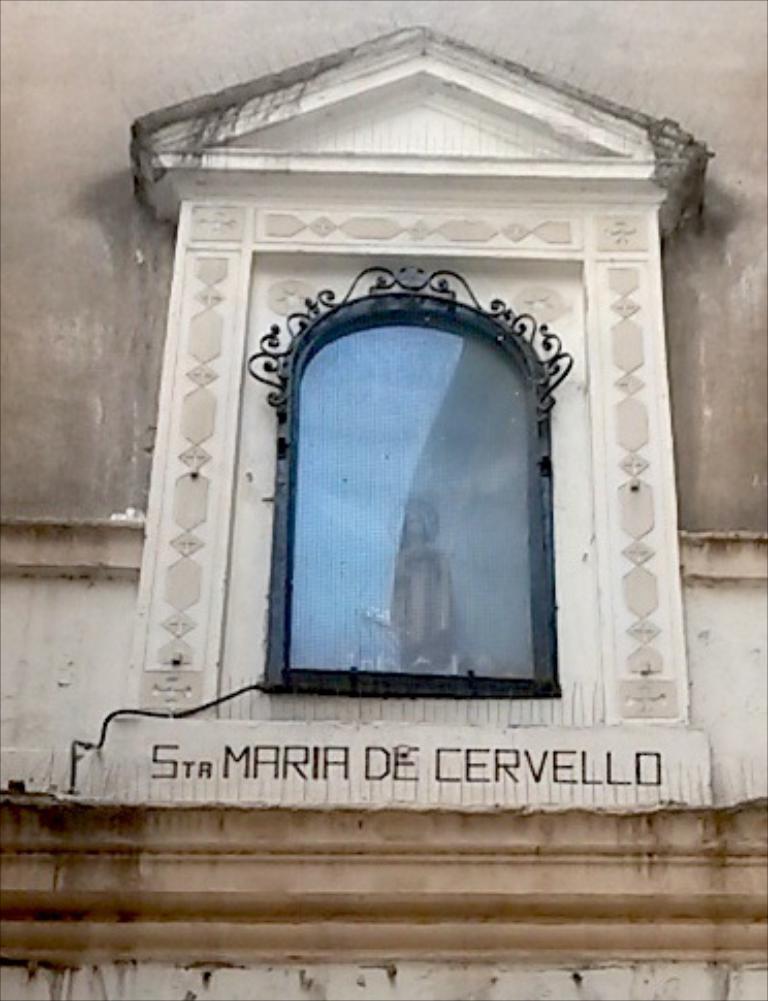Describe this image in one or two sentences. In the picture I can see a wall, a glass object, a sculpture and something written on the wall. 